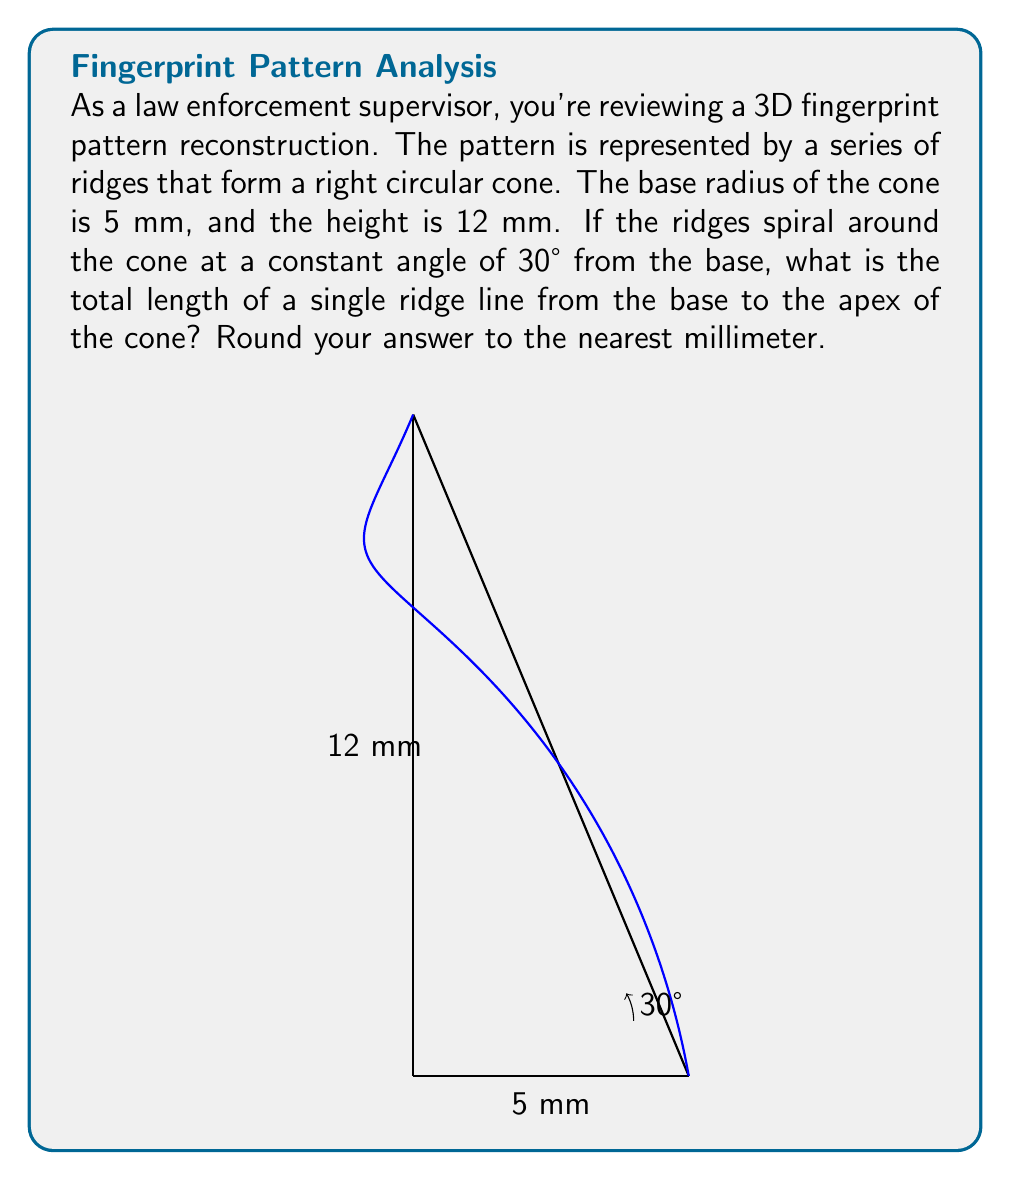Can you answer this question? To solve this problem, we'll follow these steps:

1) First, we need to understand that the ridge forms a helix on the surface of the cone. The length of this helix is what we're trying to find.

2) For a right circular cone, we can "unwrap" the surface to form a sector of a circle. The arc length of this sector will be the circumference of the base of the cone.

3) The radius of this sector (let's call it $R$) can be calculated using the Pythagorean theorem:

   $$R = \sqrt{5^2 + 12^2} = \sqrt{25 + 144} = \sqrt{169} = 13$$ mm

4) Now, imagine "unwrapping" the cone. The ridge line will form a straight line on this unwrapped surface. We need to find the length of this line.

5) The angle this line makes with the base of the unwrapped cone is given (30°). We can use this to form a right triangle.

6) The base of this triangle is the arc length of the sector, which is the circumference of the cone's base:

   $$2\pi r = 2\pi(5) = 10\pi$$ mm

7) Now we have a right triangle where we know one angle (30°) and the adjacent side $(10\pi)$. We can use the tangent function to find the hypotenuse, which is the length of our ridge line:

   $$\tan(30°) = \frac{12}{10\pi}$$
   $$\text{ridge length} = \frac{12}{\tan(30°)} = \frac{12}{1/\sqrt{3}} = 12\sqrt{3}$$ mm

8) $12\sqrt{3} \approx 20.78$ mm

9) Rounding to the nearest millimeter gives us 21 mm.
Answer: 21 mm 